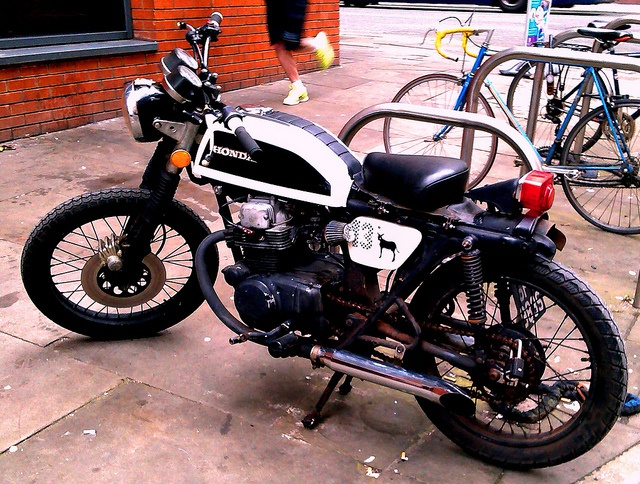Describe the objects in this image and their specific colors. I can see motorcycle in black, lavender, gray, and lightpink tones, bicycle in black, lavender, lightpink, and gray tones, and people in black, white, salmon, and maroon tones in this image. 